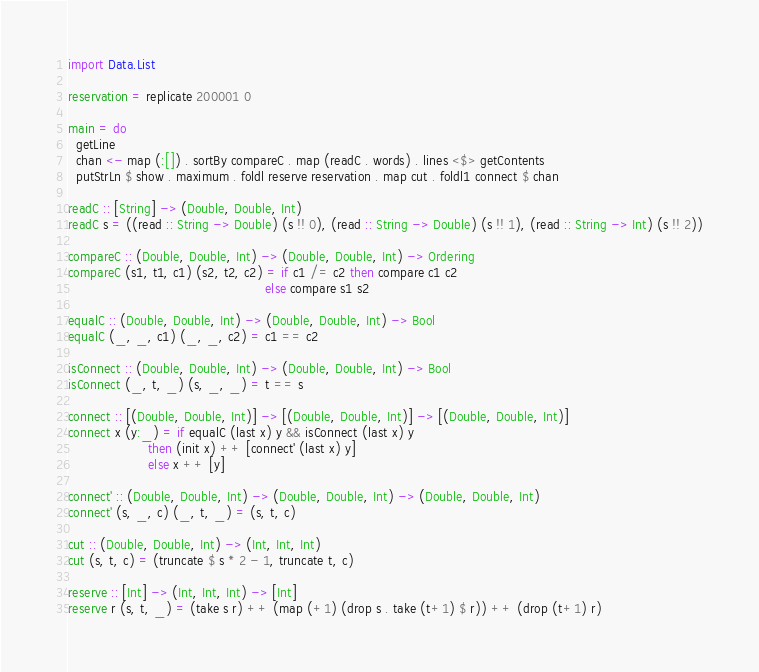Convert code to text. <code><loc_0><loc_0><loc_500><loc_500><_Haskell_>import Data.List

reservation = replicate 200001 0

main = do
  getLine
  chan <- map (:[]) . sortBy compareC . map (readC . words) . lines <$> getContents
  putStrLn $ show . maximum . foldl reserve reservation . map cut . foldl1 connect $ chan

readC :: [String] -> (Double, Double, Int)
readC s = ((read :: String -> Double) (s !! 0), (read :: String -> Double) (s !! 1), (read :: String -> Int) (s !! 2))

compareC :: (Double, Double, Int) -> (Double, Double, Int) -> Ordering
compareC (s1, t1, c1) (s2, t2, c2) = if c1 /= c2 then compare c1 c2
                                                 else compare s1 s2

equalC :: (Double, Double, Int) -> (Double, Double, Int) -> Bool
equalC (_, _, c1) (_, _, c2) = c1 == c2

isConnect :: (Double, Double, Int) -> (Double, Double, Int) -> Bool
isConnect (_, t, _) (s, _, _) = t == s

connect :: [(Double, Double, Int)] -> [(Double, Double, Int)] -> [(Double, Double, Int)]
connect x (y:_) = if equalC (last x) y && isConnect (last x) y
                    then (init x) ++ [connect' (last x) y]
                    else x ++ [y]

connect' :: (Double, Double, Int) -> (Double, Double, Int) -> (Double, Double, Int)
connect' (s, _, c) (_, t, _) = (s, t, c)

cut :: (Double, Double, Int) -> (Int, Int, Int)
cut (s, t, c) = (truncate $ s * 2 - 1, truncate t, c)

reserve :: [Int] -> (Int, Int, Int) -> [Int]
reserve r (s, t, _) = (take s r) ++ (map (+1) (drop s . take (t+1) $ r)) ++ (drop (t+1) r)
</code> 